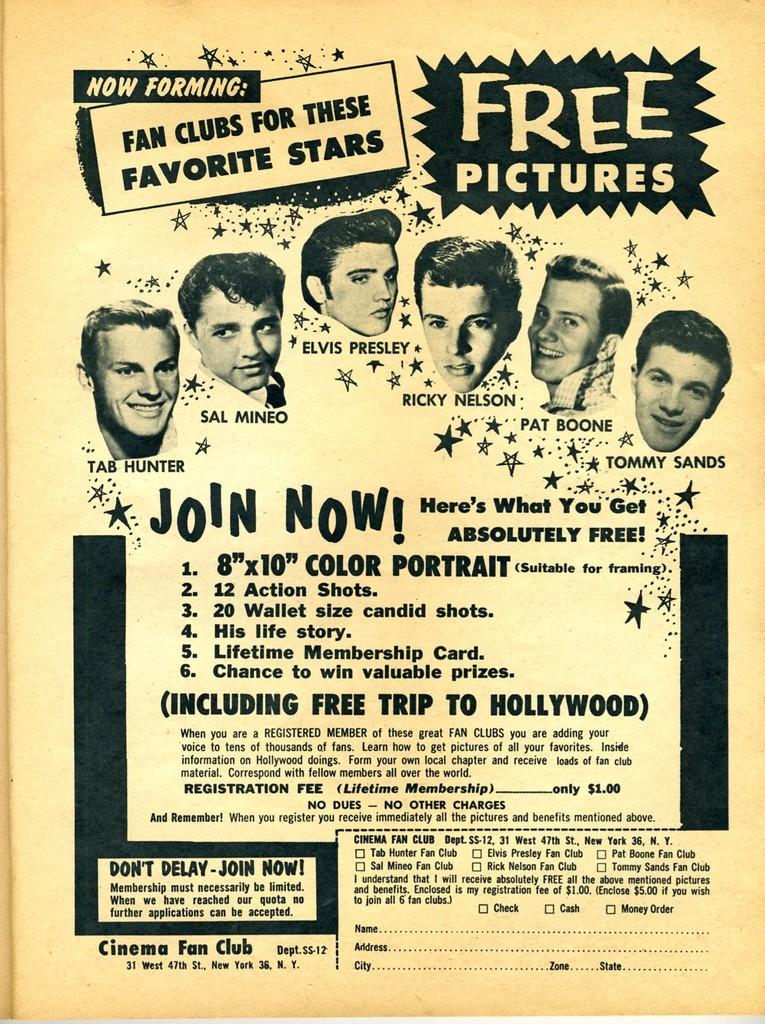What is depicted in the foreground of the poster? There are images of person's heads in the foreground of the poster. What else can be found on the poster besides the images of heads? There is text present in the poster. How many trains are visible in the poster? There are no trains present in the poster; it features images of person's heads and text. What idea is being measured in the poster? There is no mention of an idea being measured in the poster; it primarily consists of images of heads and text. 